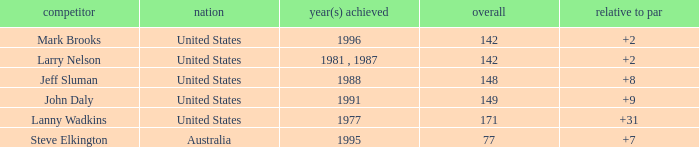Name the Total of jeff sluman? 148.0. 